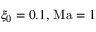Convert formula to latex. <formula><loc_0><loc_0><loc_500><loc_500>\xi _ { 0 } = 0 . 1 , \, M a = 1</formula> 